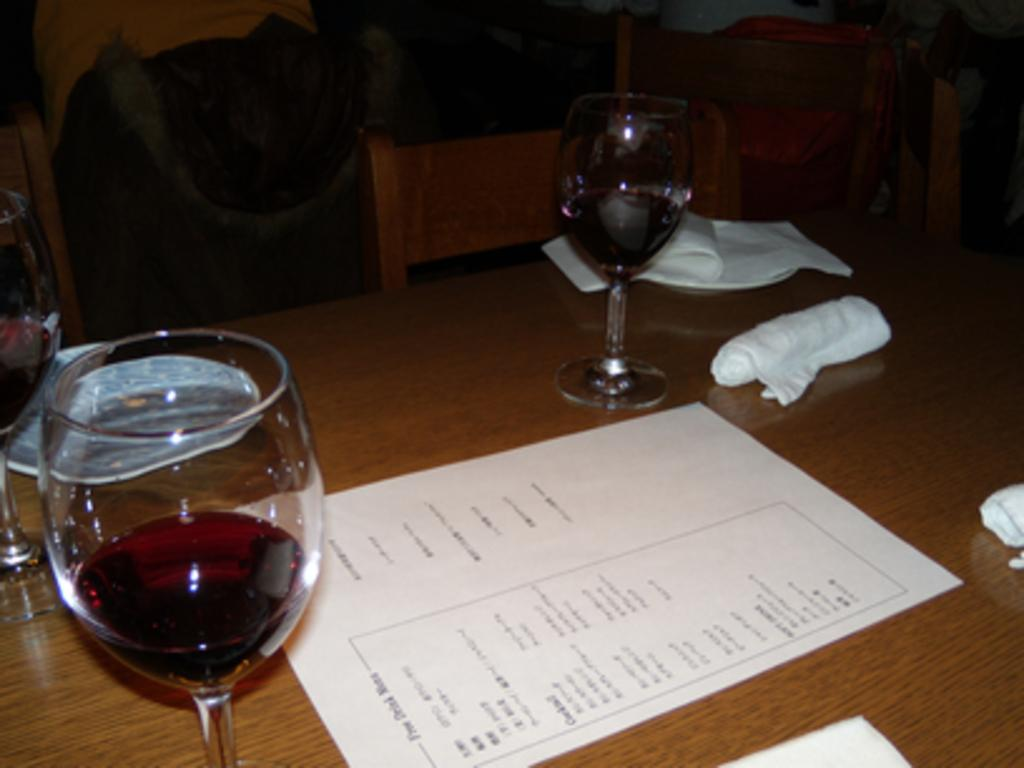What objects are on the table in the image? There are glasses on the table in the image. What type of furniture is visible in the image? There are chairs in the image. What might be used for cleaning or wiping in the image? Napkins are present in the image for cleaning or wiping. What type of shirt is being worn by the friction in the image? There is no friction or shirt present in the image. 